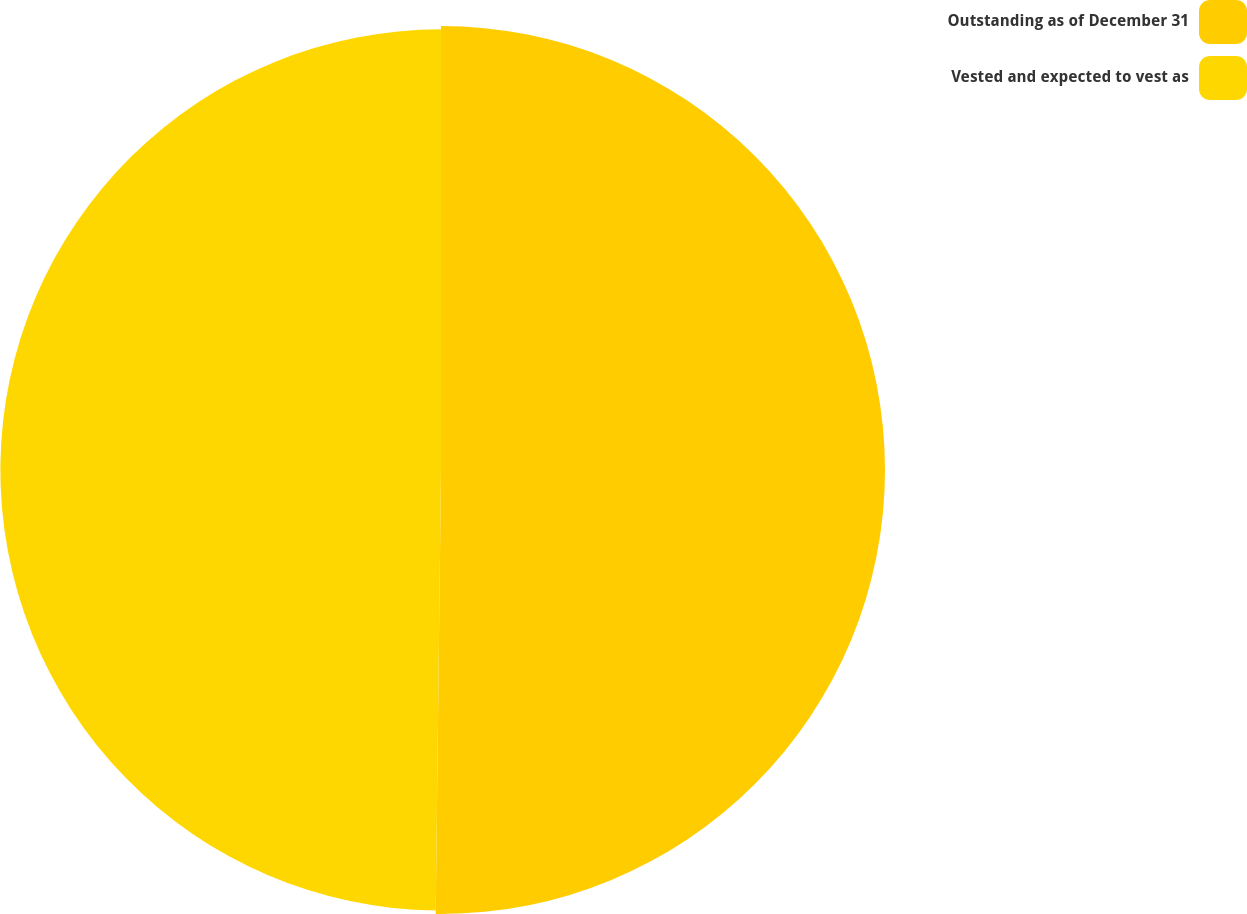Convert chart. <chart><loc_0><loc_0><loc_500><loc_500><pie_chart><fcel>Outstanding as of December 31<fcel>Vested and expected to vest as<nl><fcel>50.19%<fcel>49.81%<nl></chart> 